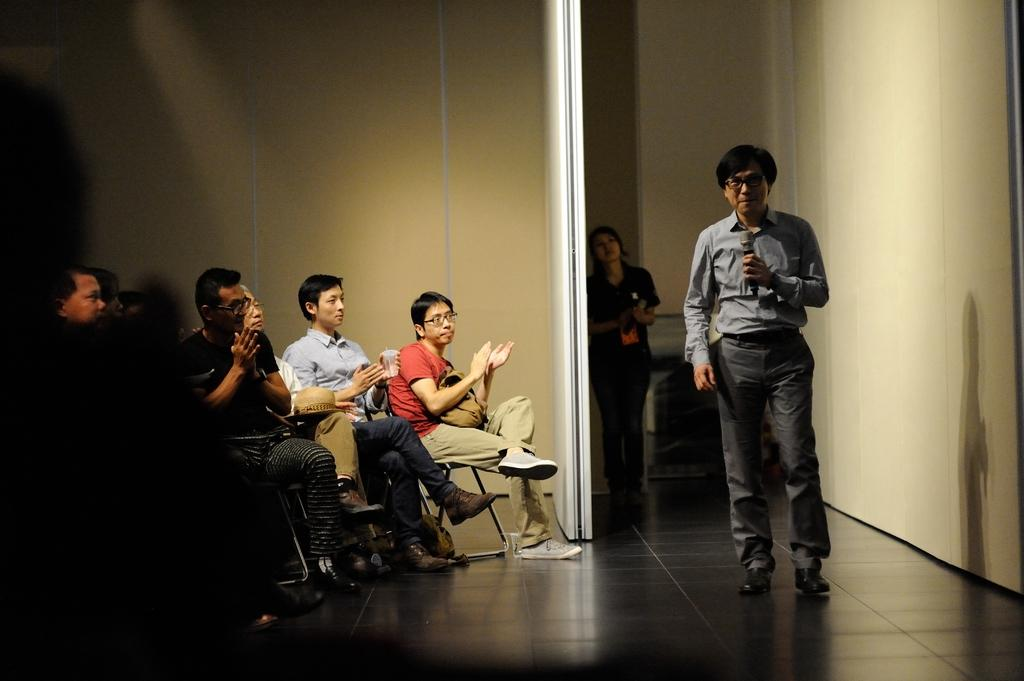How many people are in the image? There are people in the image, but the exact number is not specified. What type of furniture is present in the image? There are chairs in the image. What device is used for amplifying sound in the image? There is a microphone in the image. What type of architectural element is visible in the image? There is a wall in the image. What surface is the people and chairs standing on in the image? There is a floor in the image. What objects can be seen on the floor in the image? There are objects on the floor in the image, but their specific nature is not mentioned. Can you describe a reflection in the image? There is a reflection of a person on the wall in the image. Can you see any harbors in the image? There is no mention of a harbor in the image. What type of cracker is being used as a prop in the image? There is no mention of a cracker in the image. 